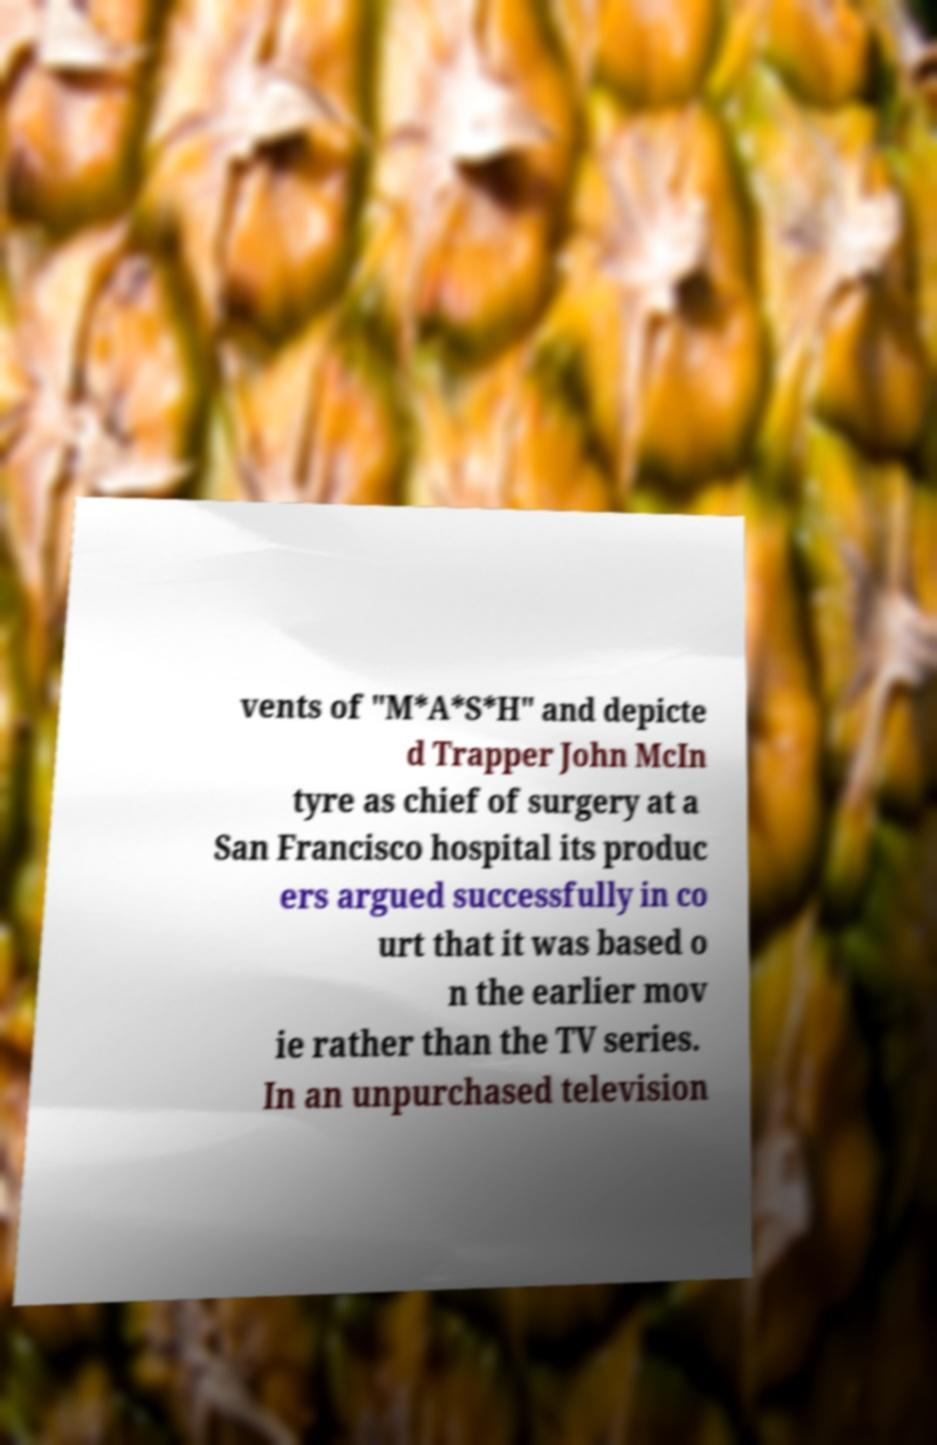Please identify and transcribe the text found in this image. vents of "M*A*S*H" and depicte d Trapper John McIn tyre as chief of surgery at a San Francisco hospital its produc ers argued successfully in co urt that it was based o n the earlier mov ie rather than the TV series. In an unpurchased television 